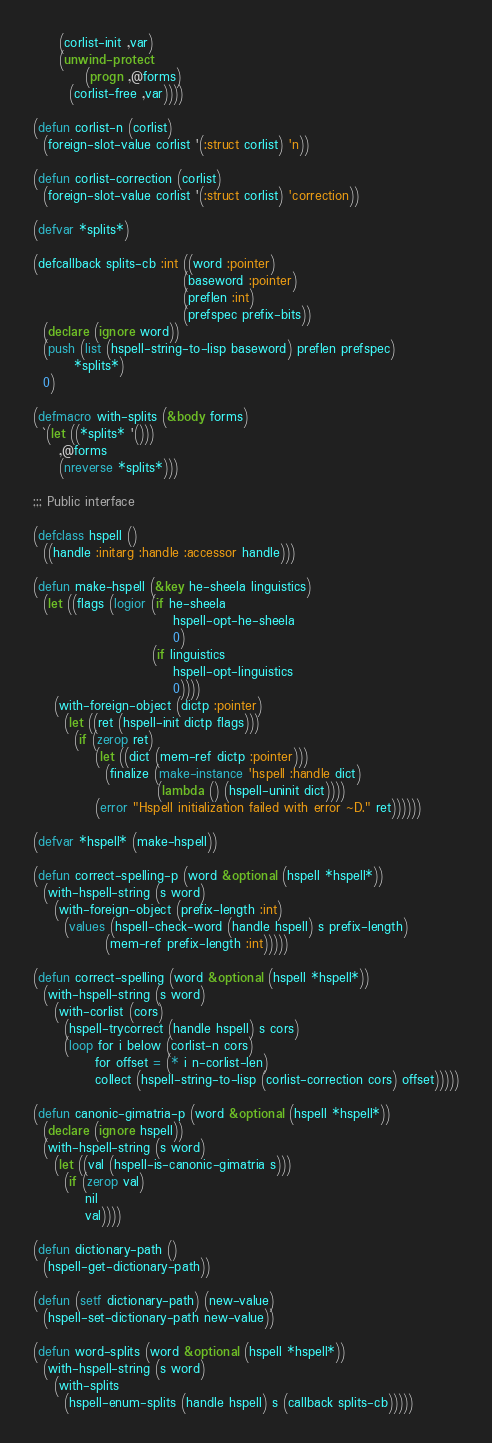<code> <loc_0><loc_0><loc_500><loc_500><_Lisp_>     (corlist-init ,var)
     (unwind-protect
          (progn ,@forms)
       (corlist-free ,var))))

(defun corlist-n (corlist)
  (foreign-slot-value corlist '(:struct corlist) 'n))

(defun corlist-correction (corlist)
  (foreign-slot-value corlist '(:struct corlist) 'correction))

(defvar *splits*)

(defcallback splits-cb :int ((word :pointer)
                             (baseword :pointer)
                             (preflen :int)
                             (prefspec prefix-bits))
  (declare (ignore word))
  (push (list (hspell-string-to-lisp baseword) preflen prefspec)
        *splits*)
  0)

(defmacro with-splits (&body forms)
  `(let ((*splits* '()))
     ,@forms
     (nreverse *splits*)))

;;; Public interface

(defclass hspell ()
  ((handle :initarg :handle :accessor handle)))

(defun make-hspell (&key he-sheela linguistics)
  (let ((flags (logior (if he-sheela
                           hspell-opt-he-sheela
                           0)
                       (if linguistics
                           hspell-opt-linguistics
                           0))))
    (with-foreign-object (dictp :pointer)
      (let ((ret (hspell-init dictp flags)))
        (if (zerop ret)
            (let ((dict (mem-ref dictp :pointer)))
              (finalize (make-instance 'hspell :handle dict)
                        (lambda () (hspell-uninit dict))))
            (error "Hspell initialization failed with error ~D." ret))))))

(defvar *hspell* (make-hspell))

(defun correct-spelling-p (word &optional (hspell *hspell*))
  (with-hspell-string (s word)
    (with-foreign-object (prefix-length :int)
      (values (hspell-check-word (handle hspell) s prefix-length)
              (mem-ref prefix-length :int)))))

(defun correct-spelling (word &optional (hspell *hspell*))
  (with-hspell-string (s word)
    (with-corlist (cors)
      (hspell-trycorrect (handle hspell) s cors)
      (loop for i below (corlist-n cors)
            for offset = (* i n-corlist-len)
            collect (hspell-string-to-lisp (corlist-correction cors) offset)))))

(defun canonic-gimatria-p (word &optional (hspell *hspell*))
  (declare (ignore hspell))
  (with-hspell-string (s word)
    (let ((val (hspell-is-canonic-gimatria s)))
      (if (zerop val)
          nil
          val))))

(defun dictionary-path ()
  (hspell-get-dictionary-path))

(defun (setf dictionary-path) (new-value)
  (hspell-set-dictionary-path new-value))

(defun word-splits (word &optional (hspell *hspell*))
  (with-hspell-string (s word)
    (with-splits
      (hspell-enum-splits (handle hspell) s (callback splits-cb)))))
</code> 